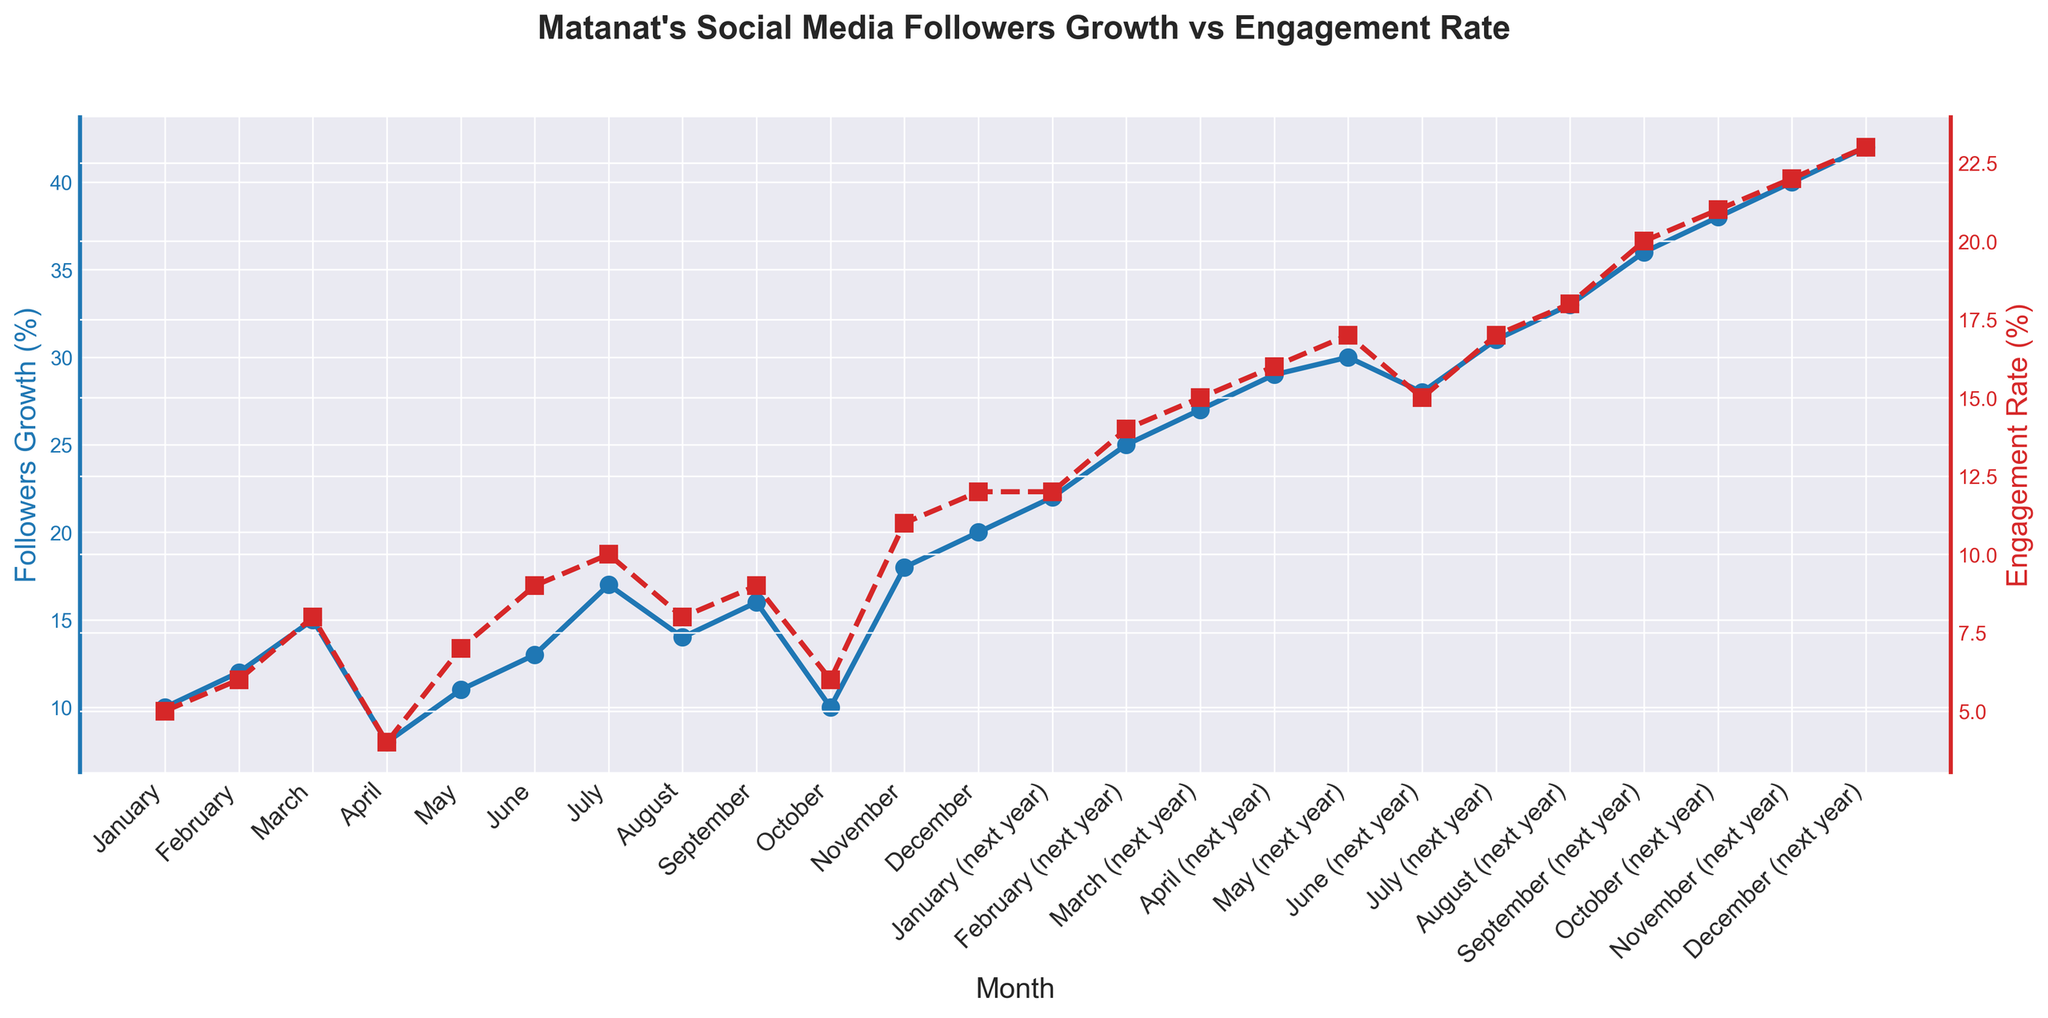What is the followers growth rate in March of the next year? The figure shows monthly growth rates for followers. Locate March of the next year and read the number associated with it.
Answer: 27% Which month has the highest engagement rate, and what is the value? Identify the data point that reaches the highest on the red dashed line, representing the engagement rate.
Answer: December of the next year, 23% How does the followers growth rate in April of this year compare to April of the next year? Look at both data points for April in each year on the blue line, and compare the values visually.
Answer: April of next year is higher What's the difference in engagement rates between September of this year and September of next year? Find the engagement rate in both Septembers on the red dashed line and subtract the earlier one from the later one.
Answer: 11% What is the average followers growth for the months of August, September, and October of next year? Add the followers growth rates for August, September, and October of next year, and divide by 3 for the average. Calculation: (33 + 36 + 38) / 3 = 35.67
Answer: 35.67 Which month has a greater engagement rate, June or July of the next year? Compare the engagement rates for June and July of next year by examining the values on the red dashed line.
Answer: July If you sum up the engagement rates for the first three months of the next year, what is the result? Add the engagement rates for January, February, and March of the next year based on red dashed line values. Calculation: 12 + 14 + 15 = 41
Answer: 41 Does any month in the first year have an engagement rate higher than the lowest engagement rate in the second year? Evaluate all engagement rates from the first year against the lowest in the second year by visually comparing the red dashed line heights.
Answer: No 